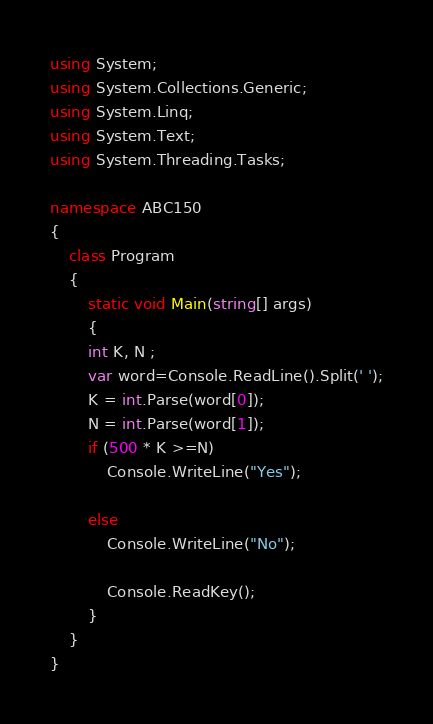Convert code to text. <code><loc_0><loc_0><loc_500><loc_500><_C#_>using System;
using System.Collections.Generic;
using System.Linq;
using System.Text;
using System.Threading.Tasks;

namespace ABC150
{
	class Program
	{
		static void Main(string[] args)
		{
		int K, N ;
        var word=Console.ReadLine().Split(' ');
		K = int.Parse(word[0]);
		N = int.Parse(word[1]);
		if (500 * K >=N)
			Console.WriteLine("Yes");

		else
			Console.WriteLine("No");

		    Console.ReadKey();
		}
	}
}
</code> 